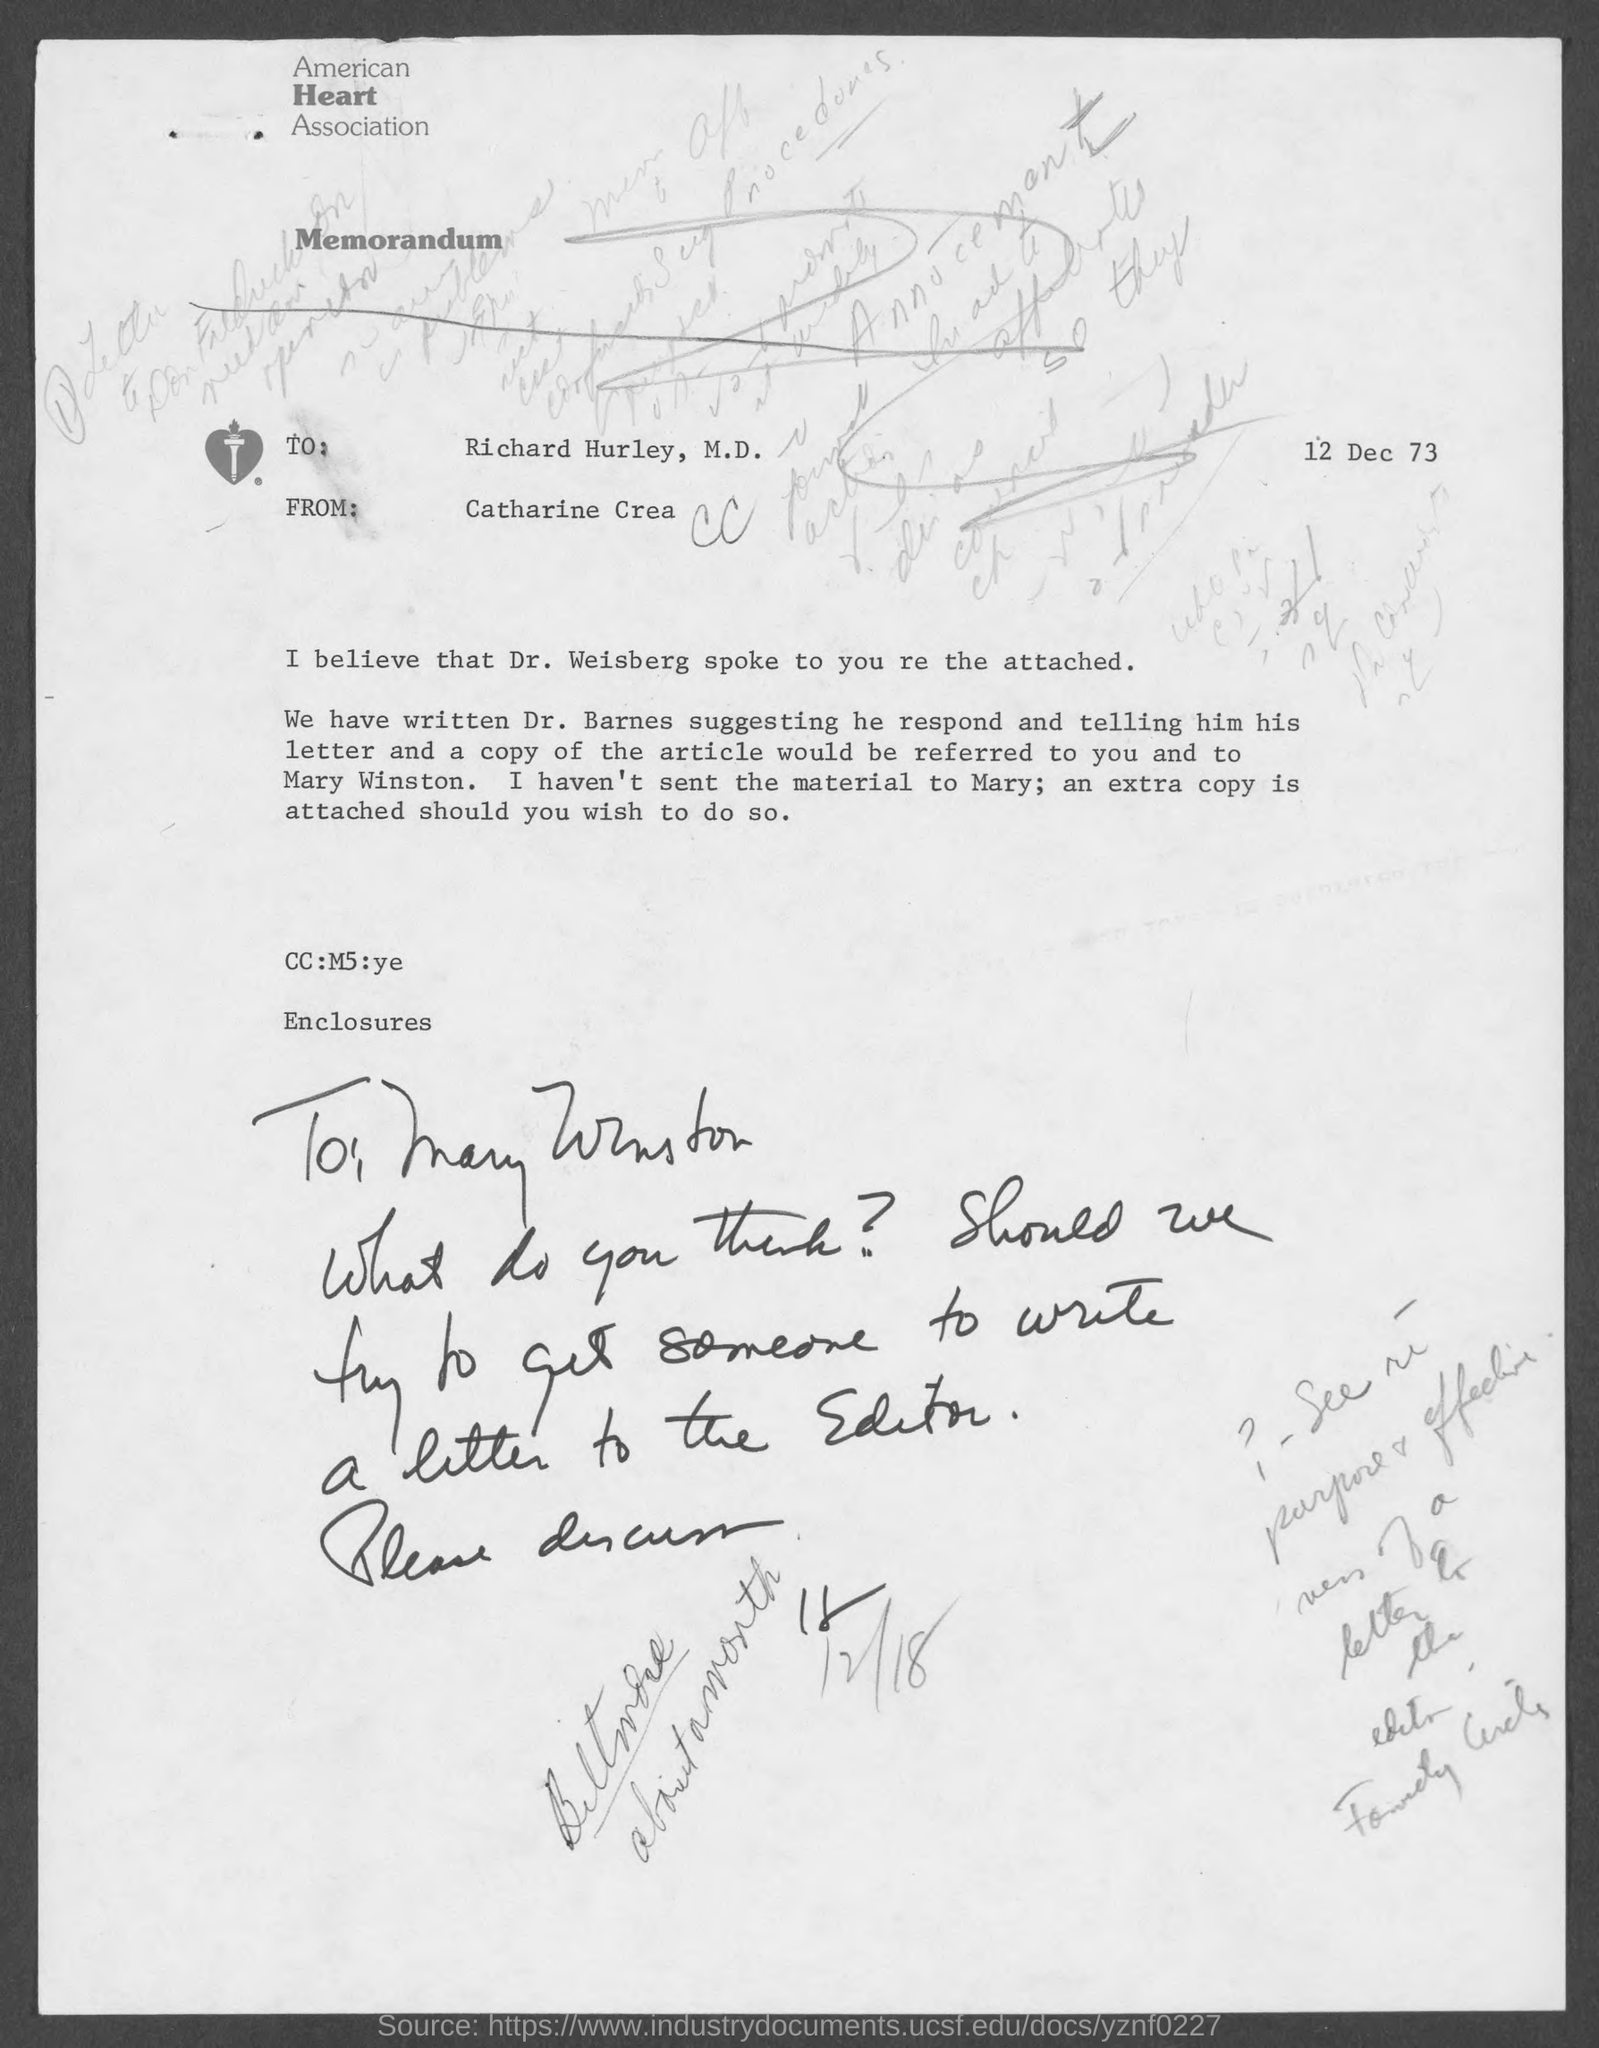Point out several critical features in this image. The author of this memorandum is Catharine Crean. The memorandum is written to Richard Hurley. The memorandum is dated December 12, 1973. The American Heart Association is the name of the heart association that appears at the top of the page. 